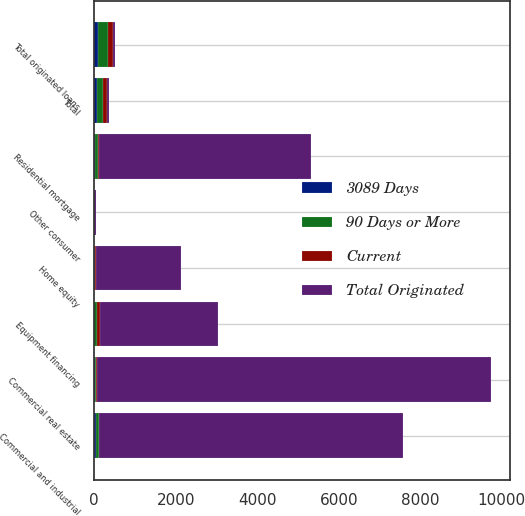<chart> <loc_0><loc_0><loc_500><loc_500><stacked_bar_chart><ecel><fcel>Commercial real estate<fcel>Commercial and industrial<fcel>Equipment financing<fcel>Total<fcel>Residential mortgage<fcel>Home equity<fcel>Other consumer<fcel>Total originated loans<nl><fcel>Total Originated<fcel>9667.7<fcel>7466.5<fcel>2886.7<fcel>52.35<fcel>5212.9<fcel>2098.9<fcel>48.2<fcel>52.35<nl><fcel>Current<fcel>15<fcel>13.1<fcel>63.9<fcel>92<fcel>31.1<fcel>7.1<fcel>0.2<fcel>130.4<nl><fcel>3089 Days<fcel>14.2<fcel>46.8<fcel>7<fcel>68<fcel>25.4<fcel>9.5<fcel>0.1<fcel>103<nl><fcel>90 Days or More<fcel>29.2<fcel>59.9<fcel>70.9<fcel>160<fcel>56.5<fcel>16.6<fcel>0.3<fcel>233.4<nl></chart> 